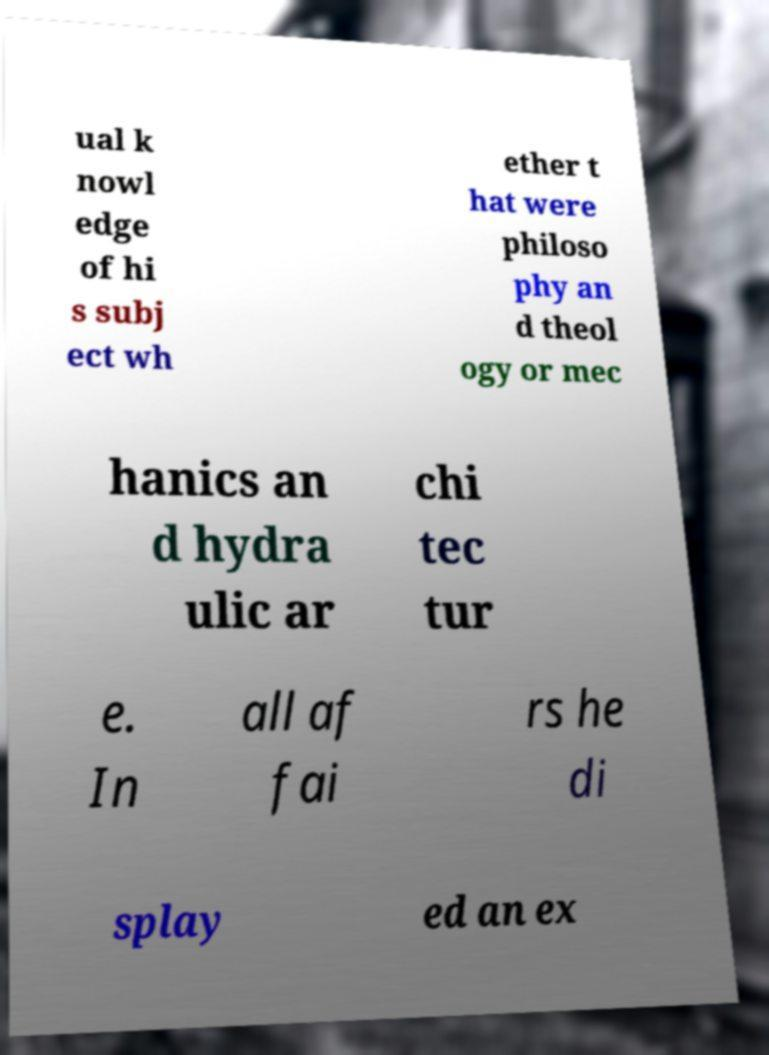Please read and relay the text visible in this image. What does it say? ual k nowl edge of hi s subj ect wh ether t hat were philoso phy an d theol ogy or mec hanics an d hydra ulic ar chi tec tur e. In all af fai rs he di splay ed an ex 